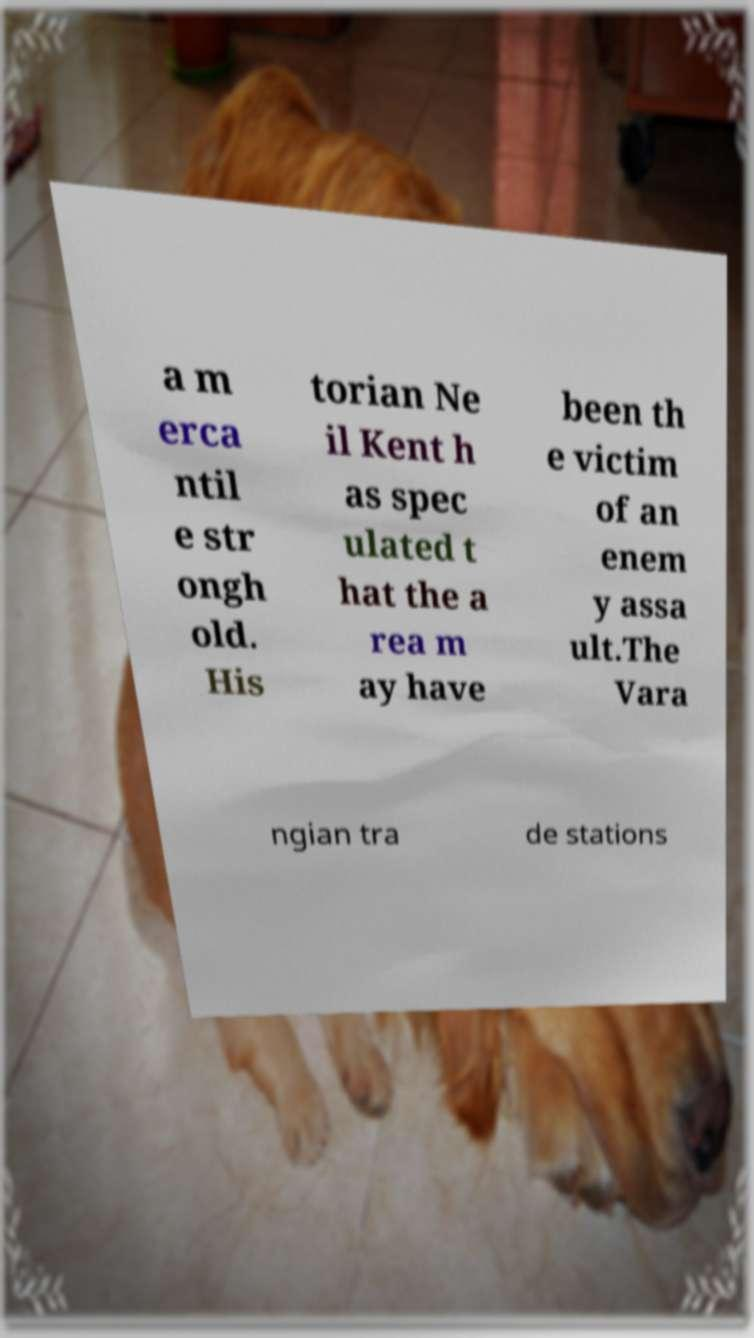What messages or text are displayed in this image? I need them in a readable, typed format. a m erca ntil e str ongh old. His torian Ne il Kent h as spec ulated t hat the a rea m ay have been th e victim of an enem y assa ult.The Vara ngian tra de stations 